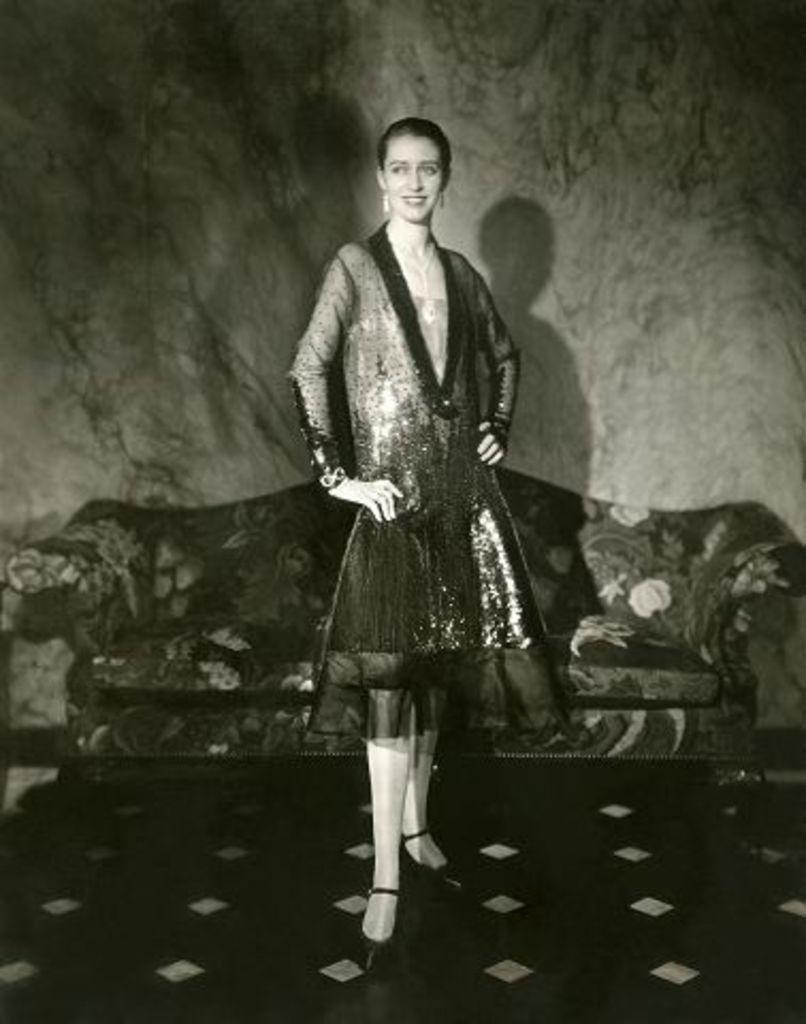Could you give a brief overview of what you see in this image? It is the black and white image in which there is a girl standing on the floor. Behind her there is a sofa. In the background there is a wall. 